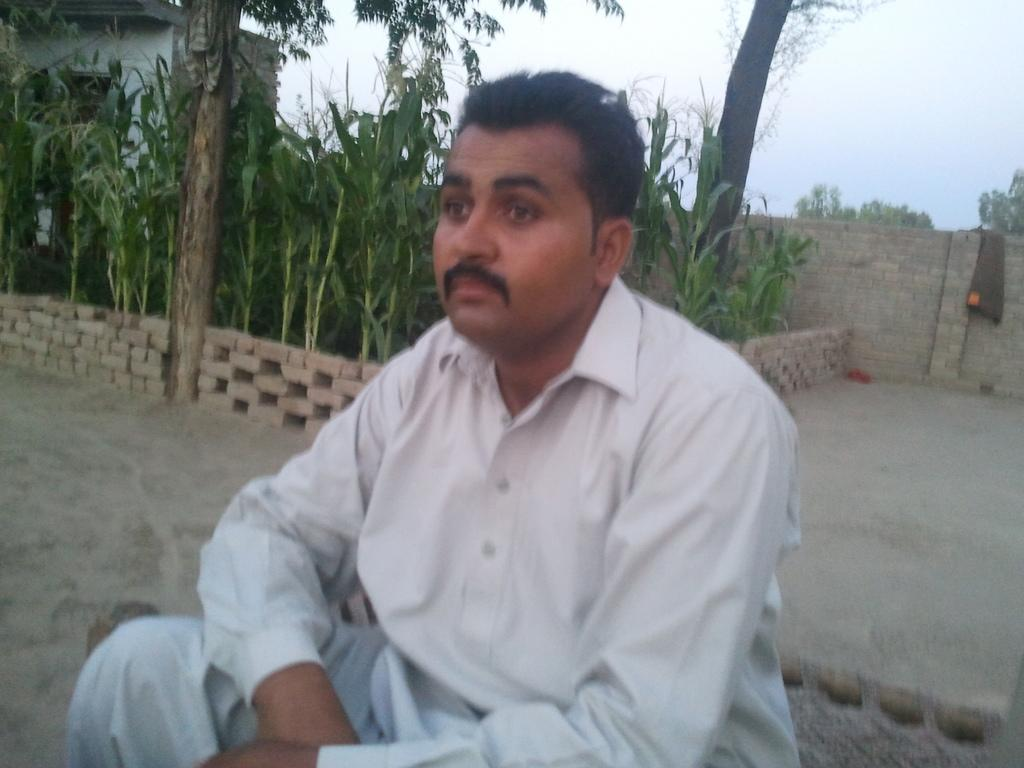What is the main subject of the image? There is a person in the image. What is the person wearing? The person is wearing a white and blue colored dress. What is the person sitting on? The person is sitting on a wooden cot. What can be seen in the background of the image? There are trees, a wall, a house, and the sky visible in the background of the image. What type of waste can be seen in the image? There is no waste present in the image. Is the coast visible in the image? The image does not depict a coast; it shows a person sitting on a wooden cot with a background of trees, a wall, a house, and the sky. 